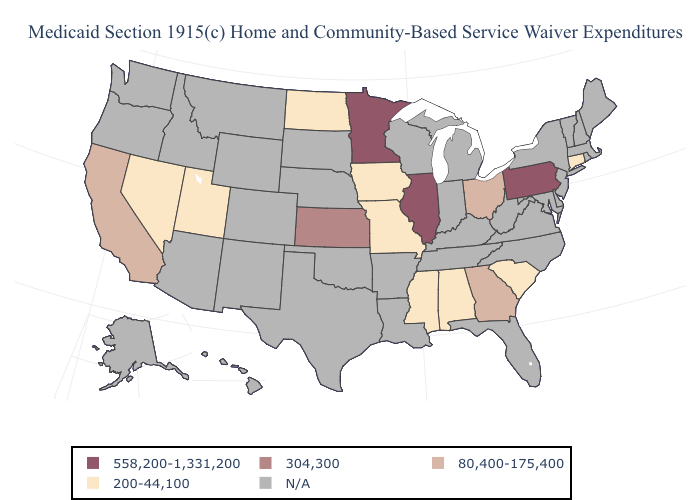What is the value of Maryland?
Short answer required. N/A. Name the states that have a value in the range 200-44,100?
Answer briefly. Alabama, Connecticut, Iowa, Mississippi, Missouri, Nevada, North Dakota, South Carolina, Utah. Among the states that border Florida , does Georgia have the highest value?
Be succinct. Yes. Name the states that have a value in the range 200-44,100?
Quick response, please. Alabama, Connecticut, Iowa, Mississippi, Missouri, Nevada, North Dakota, South Carolina, Utah. What is the lowest value in the USA?
Write a very short answer. 200-44,100. What is the lowest value in the MidWest?
Answer briefly. 200-44,100. What is the highest value in states that border Missouri?
Keep it brief. 558,200-1,331,200. Does the map have missing data?
Give a very brief answer. Yes. Does Minnesota have the highest value in the USA?
Give a very brief answer. Yes. What is the value of Oklahoma?
Answer briefly. N/A. Does Nevada have the highest value in the West?
Concise answer only. No. Does the map have missing data?
Give a very brief answer. Yes. Is the legend a continuous bar?
Write a very short answer. No. 